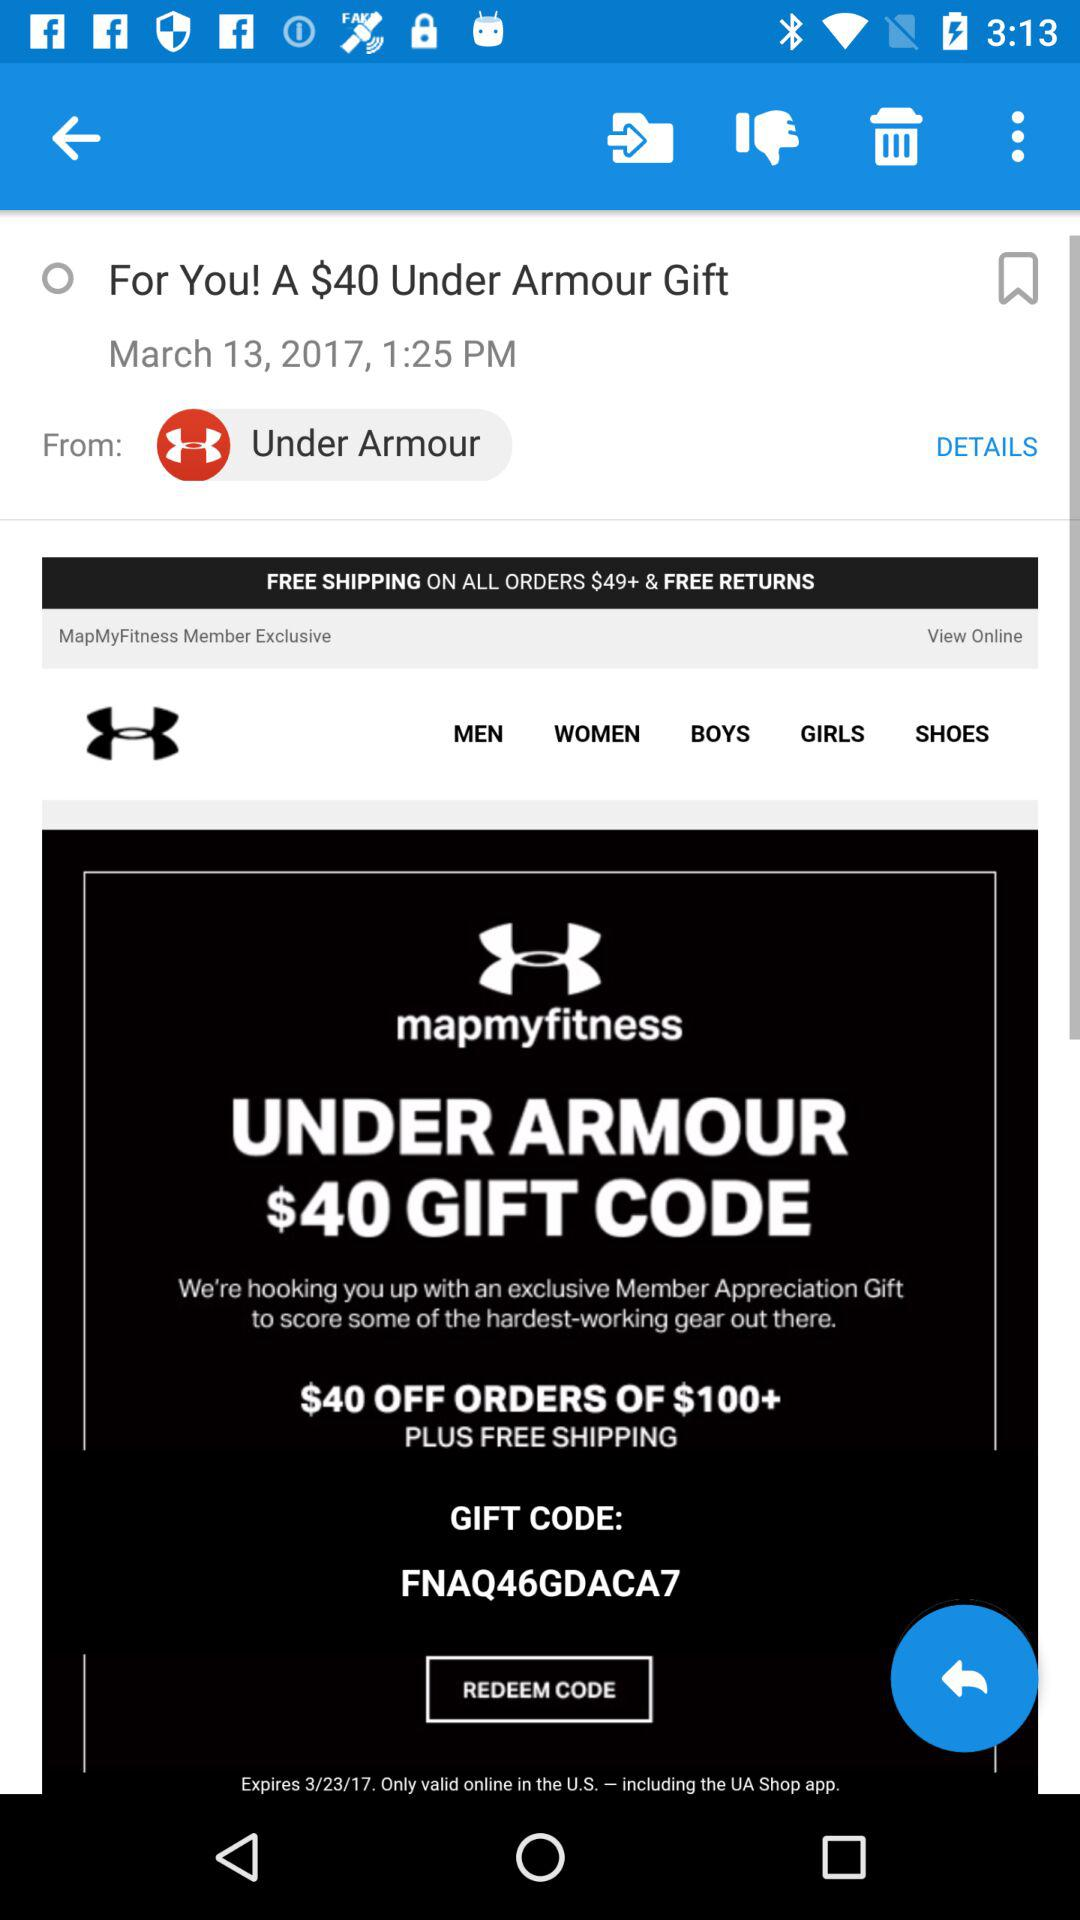On what date is this offer last updated? The date is March 13, 2017. 